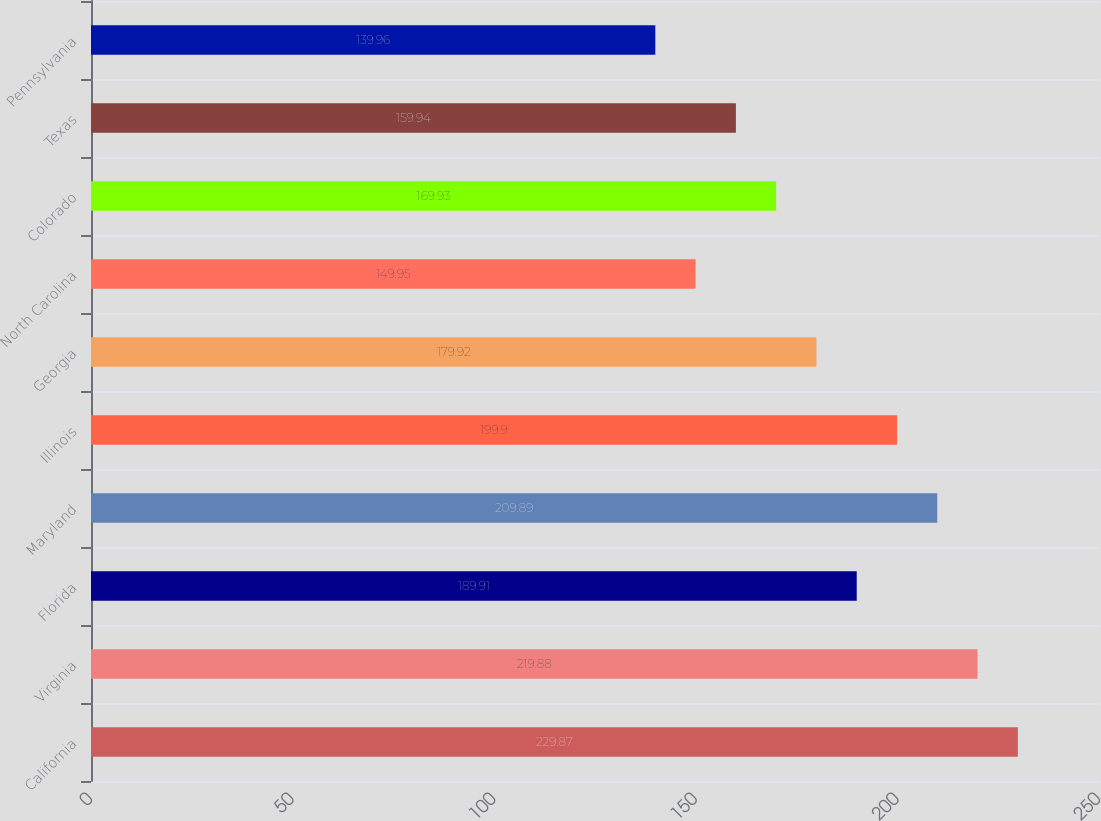Convert chart. <chart><loc_0><loc_0><loc_500><loc_500><bar_chart><fcel>California<fcel>Virginia<fcel>Florida<fcel>Maryland<fcel>Illinois<fcel>Georgia<fcel>North Carolina<fcel>Colorado<fcel>Texas<fcel>Pennsylvania<nl><fcel>229.87<fcel>219.88<fcel>189.91<fcel>209.89<fcel>199.9<fcel>179.92<fcel>149.95<fcel>169.93<fcel>159.94<fcel>139.96<nl></chart> 